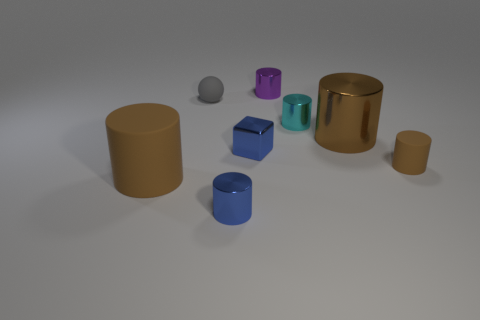There is a big brown thing that is on the left side of the purple metallic thing; does it have the same shape as the small cyan metal object?
Provide a short and direct response. Yes. How many cyan things are either small cylinders or cylinders?
Keep it short and to the point. 1. There is a purple object that is the same shape as the small cyan object; what is it made of?
Your answer should be compact. Metal. The large thing on the right side of the tiny gray rubber object has what shape?
Ensure brevity in your answer.  Cylinder. Is there a blue cylinder made of the same material as the tiny purple thing?
Offer a very short reply. Yes. Do the blue shiny cylinder and the brown metallic cylinder have the same size?
Your answer should be very brief. No. What number of cylinders are large yellow metal objects or tiny cyan metallic things?
Provide a succinct answer. 1. There is a cylinder that is the same color as the small block; what is it made of?
Make the answer very short. Metal. How many other big metallic things are the same shape as the gray thing?
Keep it short and to the point. 0. Are there more brown things that are left of the cyan shiny cylinder than small blue objects to the left of the small gray thing?
Give a very brief answer. Yes. 